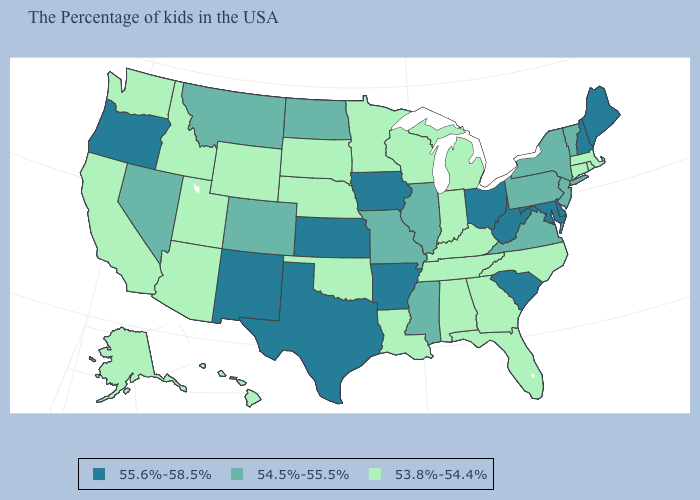Which states have the highest value in the USA?
Quick response, please. Maine, New Hampshire, Delaware, Maryland, South Carolina, West Virginia, Ohio, Arkansas, Iowa, Kansas, Texas, New Mexico, Oregon. Which states hav the highest value in the West?
Keep it brief. New Mexico, Oregon. What is the value of New Mexico?
Write a very short answer. 55.6%-58.5%. Name the states that have a value in the range 55.6%-58.5%?
Short answer required. Maine, New Hampshire, Delaware, Maryland, South Carolina, West Virginia, Ohio, Arkansas, Iowa, Kansas, Texas, New Mexico, Oregon. Which states hav the highest value in the Northeast?
Keep it brief. Maine, New Hampshire. Does the map have missing data?
Write a very short answer. No. Does the first symbol in the legend represent the smallest category?
Quick response, please. No. Name the states that have a value in the range 53.8%-54.4%?
Keep it brief. Massachusetts, Rhode Island, Connecticut, North Carolina, Florida, Georgia, Michigan, Kentucky, Indiana, Alabama, Tennessee, Wisconsin, Louisiana, Minnesota, Nebraska, Oklahoma, South Dakota, Wyoming, Utah, Arizona, Idaho, California, Washington, Alaska, Hawaii. Name the states that have a value in the range 54.5%-55.5%?
Write a very short answer. Vermont, New York, New Jersey, Pennsylvania, Virginia, Illinois, Mississippi, Missouri, North Dakota, Colorado, Montana, Nevada. Does the first symbol in the legend represent the smallest category?
Keep it brief. No. Does Oregon have the highest value in the West?
Be succinct. Yes. What is the highest value in the USA?
Write a very short answer. 55.6%-58.5%. Which states have the lowest value in the USA?
Keep it brief. Massachusetts, Rhode Island, Connecticut, North Carolina, Florida, Georgia, Michigan, Kentucky, Indiana, Alabama, Tennessee, Wisconsin, Louisiana, Minnesota, Nebraska, Oklahoma, South Dakota, Wyoming, Utah, Arizona, Idaho, California, Washington, Alaska, Hawaii. Name the states that have a value in the range 53.8%-54.4%?
Give a very brief answer. Massachusetts, Rhode Island, Connecticut, North Carolina, Florida, Georgia, Michigan, Kentucky, Indiana, Alabama, Tennessee, Wisconsin, Louisiana, Minnesota, Nebraska, Oklahoma, South Dakota, Wyoming, Utah, Arizona, Idaho, California, Washington, Alaska, Hawaii. 